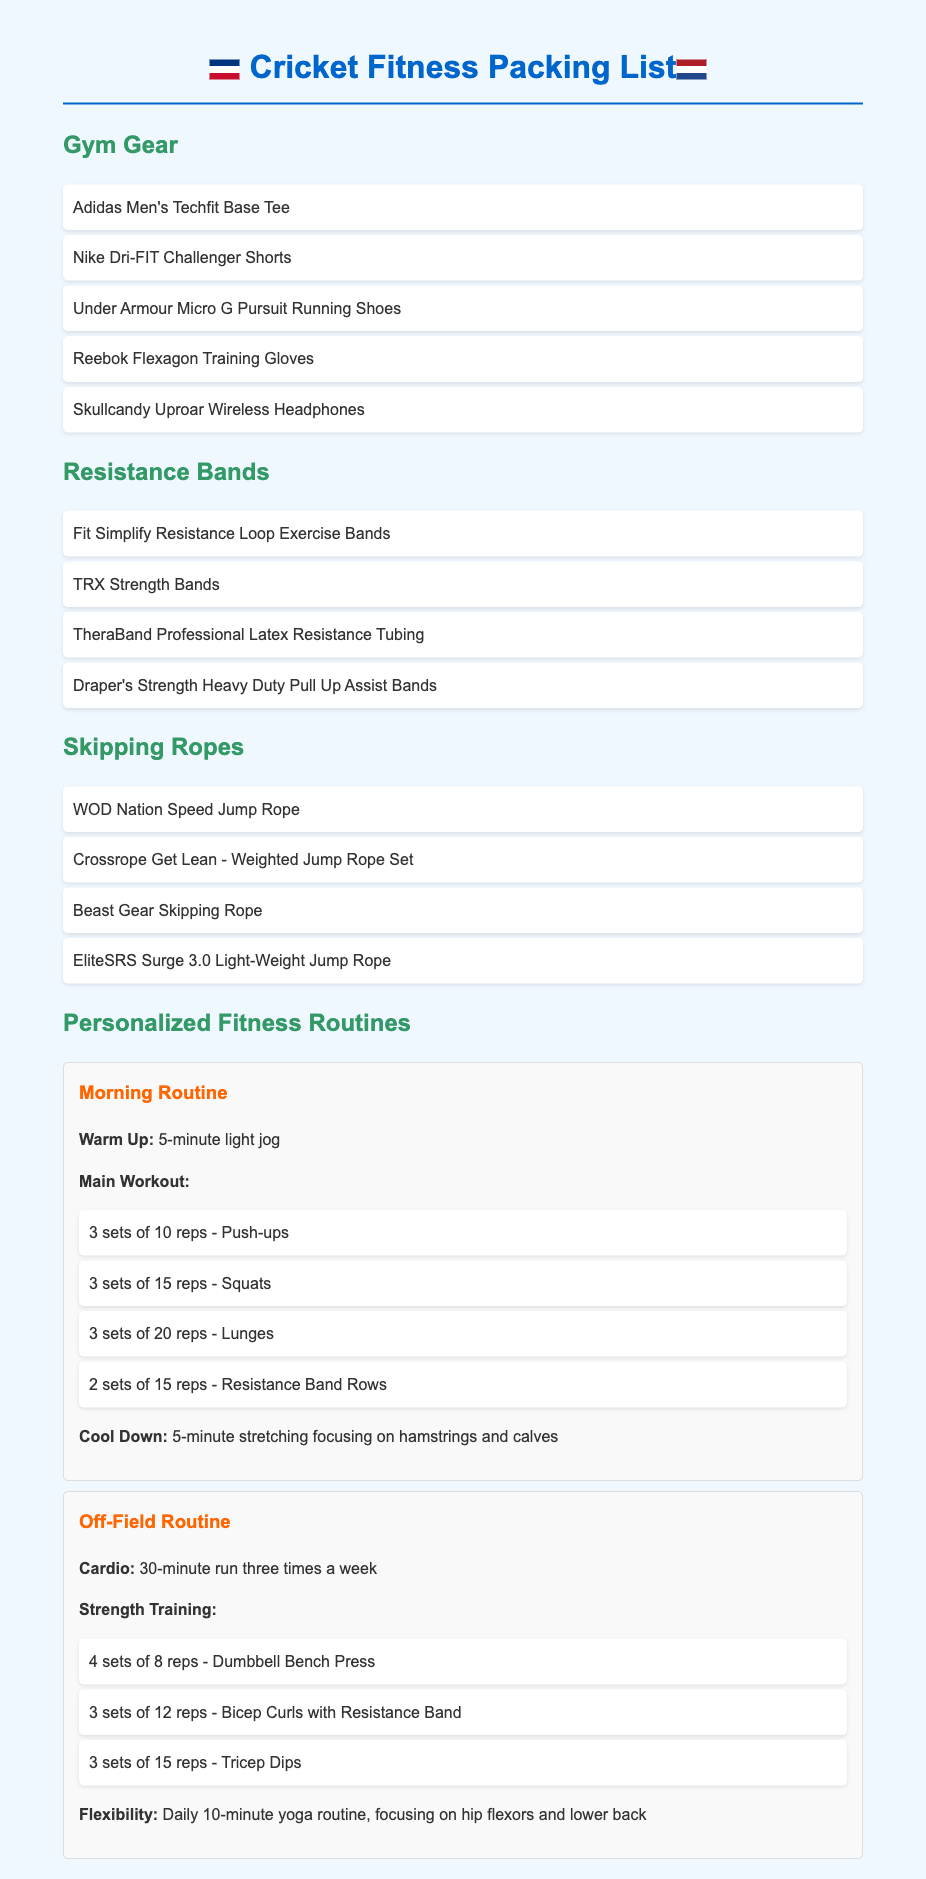what are the brands of gym gear listed? The document lists specific gym gear alongside their brands. The brands mentioned are Adidas, Nike, Under Armour, Reebok, and Skullcandy.
Answer: Adidas, Nike, Under Armour, Reebok, Skullcandy how many types of resistance bands are mentioned? The document provides a list of resistance bands, totaling four distinct types of bands.
Answer: 4 what is the first exercise in the morning routine? The morning routine starts with a warm-up exercise, which is a light jog for five minutes.
Answer: 5-minute light jog which routine includes yoga? The off-field routine includes a daily 10-minute yoga routine for flexibility.
Answer: Off-Field Routine how many reps are suggested for lunges in the morning routine? The morning routine specifies performing three sets of twenty repetitions for lunges.
Answer: 20 reps what equipment is suggested for strength training in the off-field routine? The off-field routine lists dumbbells and resistance bands for strength training exercises.
Answer: Dumbbells, resistance bands which skipping rope is mentioned with "speed" in its name? The document cites the WOD Nation Speed Jump Rope as part of the skipping ropes section.
Answer: WOD Nation Speed Jump Rope how many sets of push-ups are included in the morning routine? The morning routine requires three sets of ten repetitions for push-ups.
Answer: 3 sets what is the cardio activity suggested for the off-field routine? The off-field routine includes running as the cardio activity, specifically a 30-minute run.
Answer: 30-minute run 